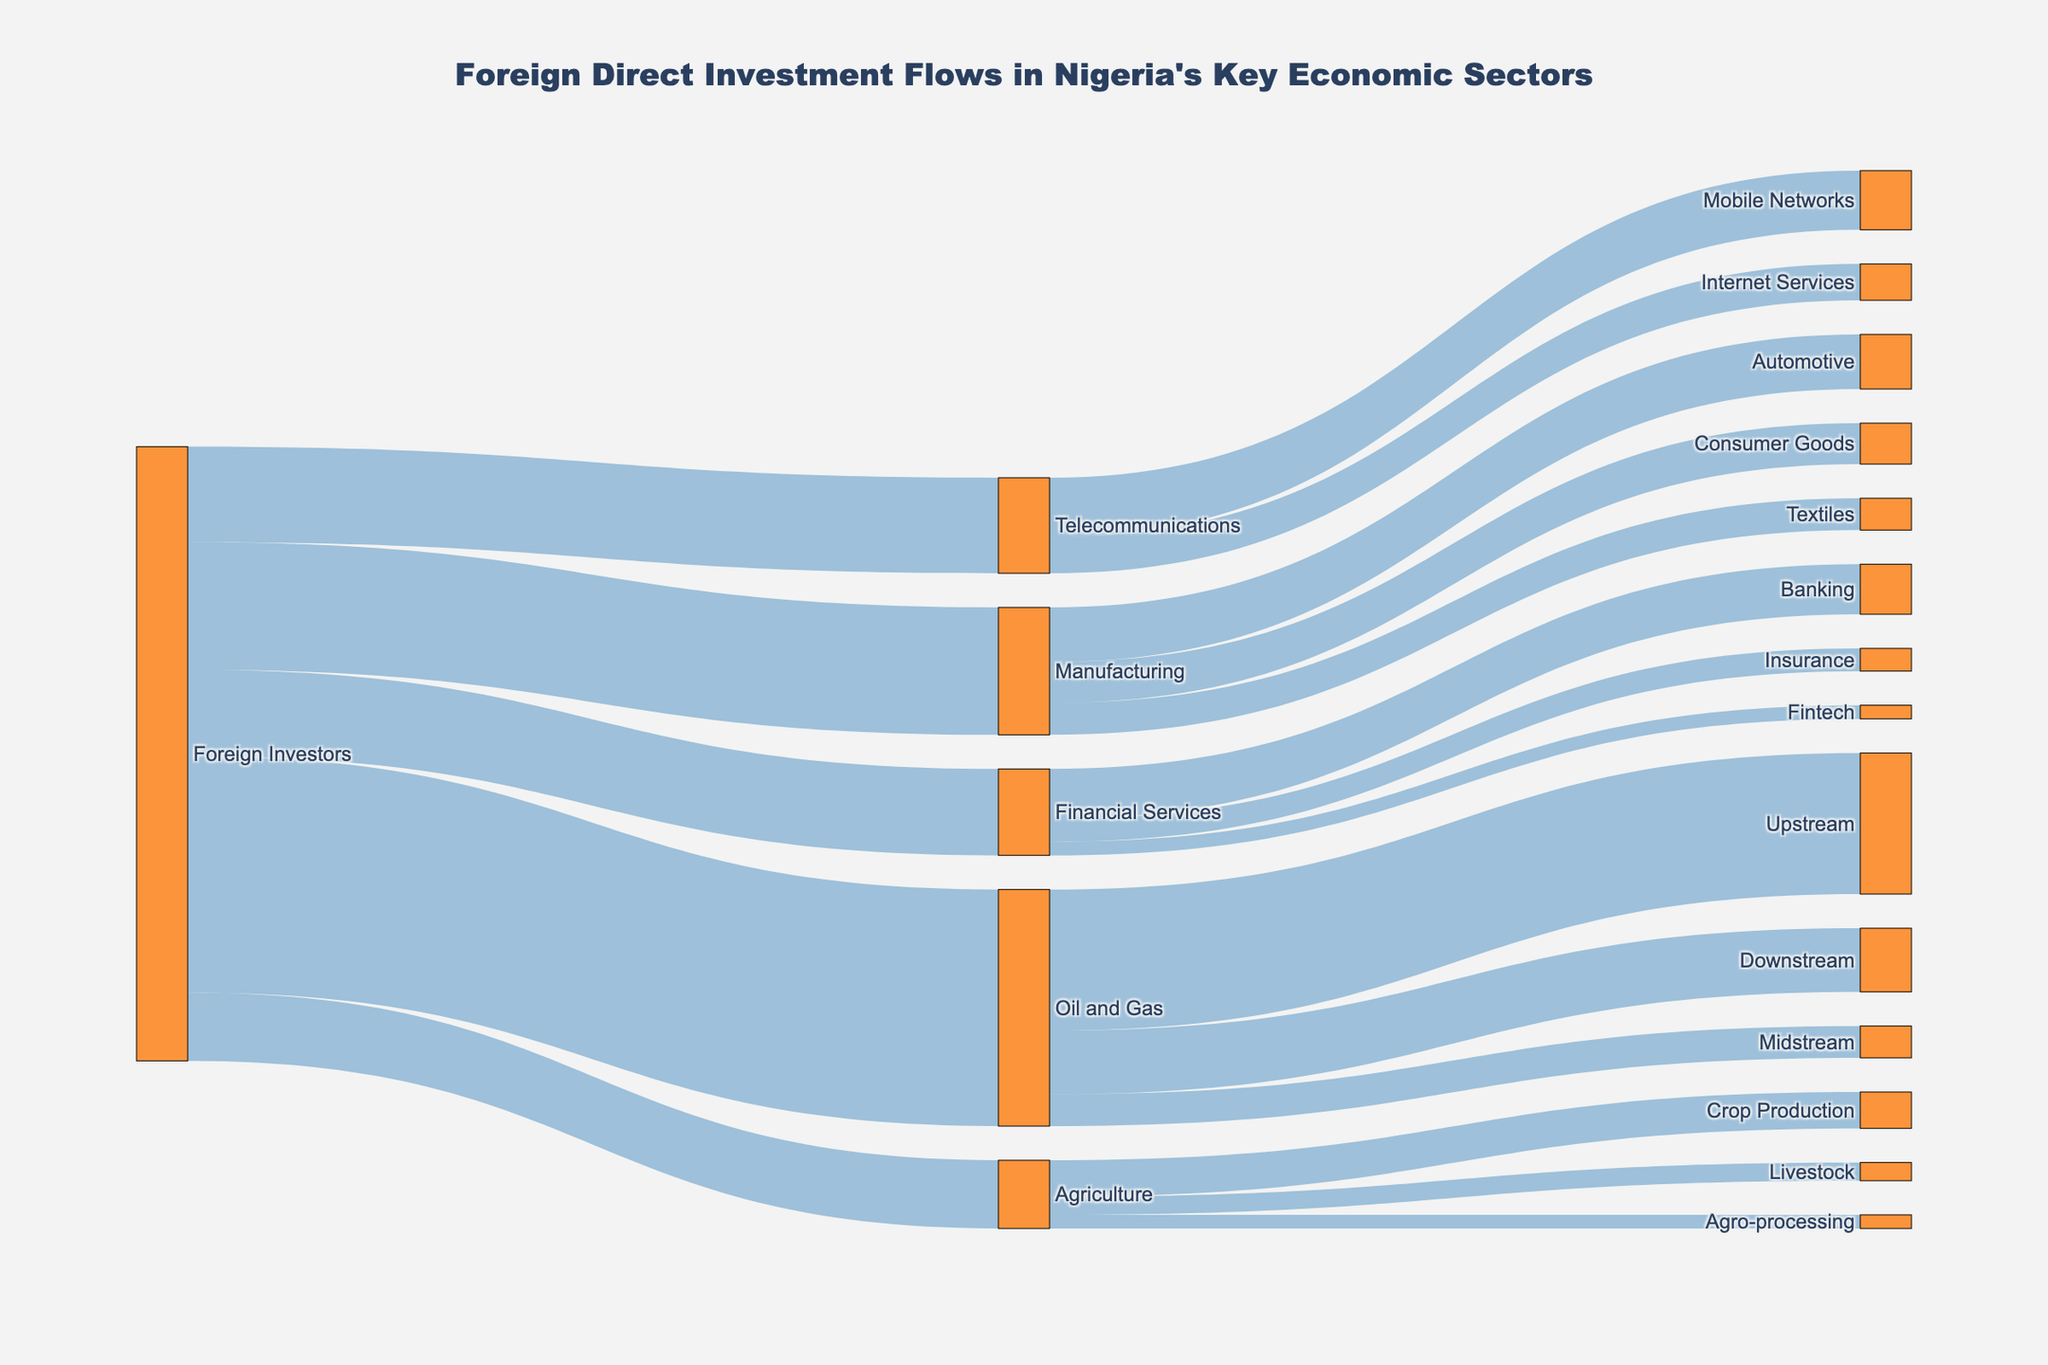What's the largest investment made by foreign investors in any sector? According to the Sankey diagram, the largest investment made by foreign investors is in the Oil and Gas sector, with a value of 5200.
Answer: 5200 Which subsector within Oil and Gas received the highest investment? By examining the connections within the Oil and Gas sector, the Upstream subsector has the highest investment, receiving 3100.
Answer: Upstream What is the total investment made by foreign investors in the Telecommunications sector? The total investment in Telecommunications can be obtained by summing the values for Mobile Networks (1300) and Internet Services (800), resulting in 2100, which matches the value shown for Telecommunications.
Answer: 2100 Which sector has the lowest investment from foreign investors? By comparing the values, Agriculture is the sector with the lowest investment from foreign investors, with a value of 1500.
Answer: Agriculture How much total investment is distributed within the Financial Services sector? Adding up the investments in Banking (1100), Insurance (500), and Fintech (300), the total investment within the Financial Services sector is 1900.
Answer: 1900 What is the difference in investment amounts between the Manufacturing and Financial Services sectors? The investment in Manufacturing is 2800, while in Financial Services it is 1900. The difference is 2800 - 1900, which equals 900.
Answer: 900 Which subsector in Agriculture receives the least investment? Among Crop Production (800), Livestock (400), and Agro-processing (300), Agro-processing receives the least investment.
Answer: Agro-processing How does the investment in Livestock compare to that in the Fintech? The investment in Livestock is 400, which is greater than the investment in Fintech, which is 300.
Answer: Livestock has a greater investment What percentage of the total investment in Manufacturing goes into the Automotive subsector? The total investment in Manufacturing is 2800, and the investment in Automotive is 1200. The percentage is (1200 / 2800) * 100, which equals approximately 42.86%.
Answer: 42.86% Which sector has more investment: Oil and Gas or Manufacturing? The investment in Oil and Gas is 5200, while in Manufacturing it is 2800. Oil and Gas has more investment than Manufacturing.
Answer: Oil and Gas 